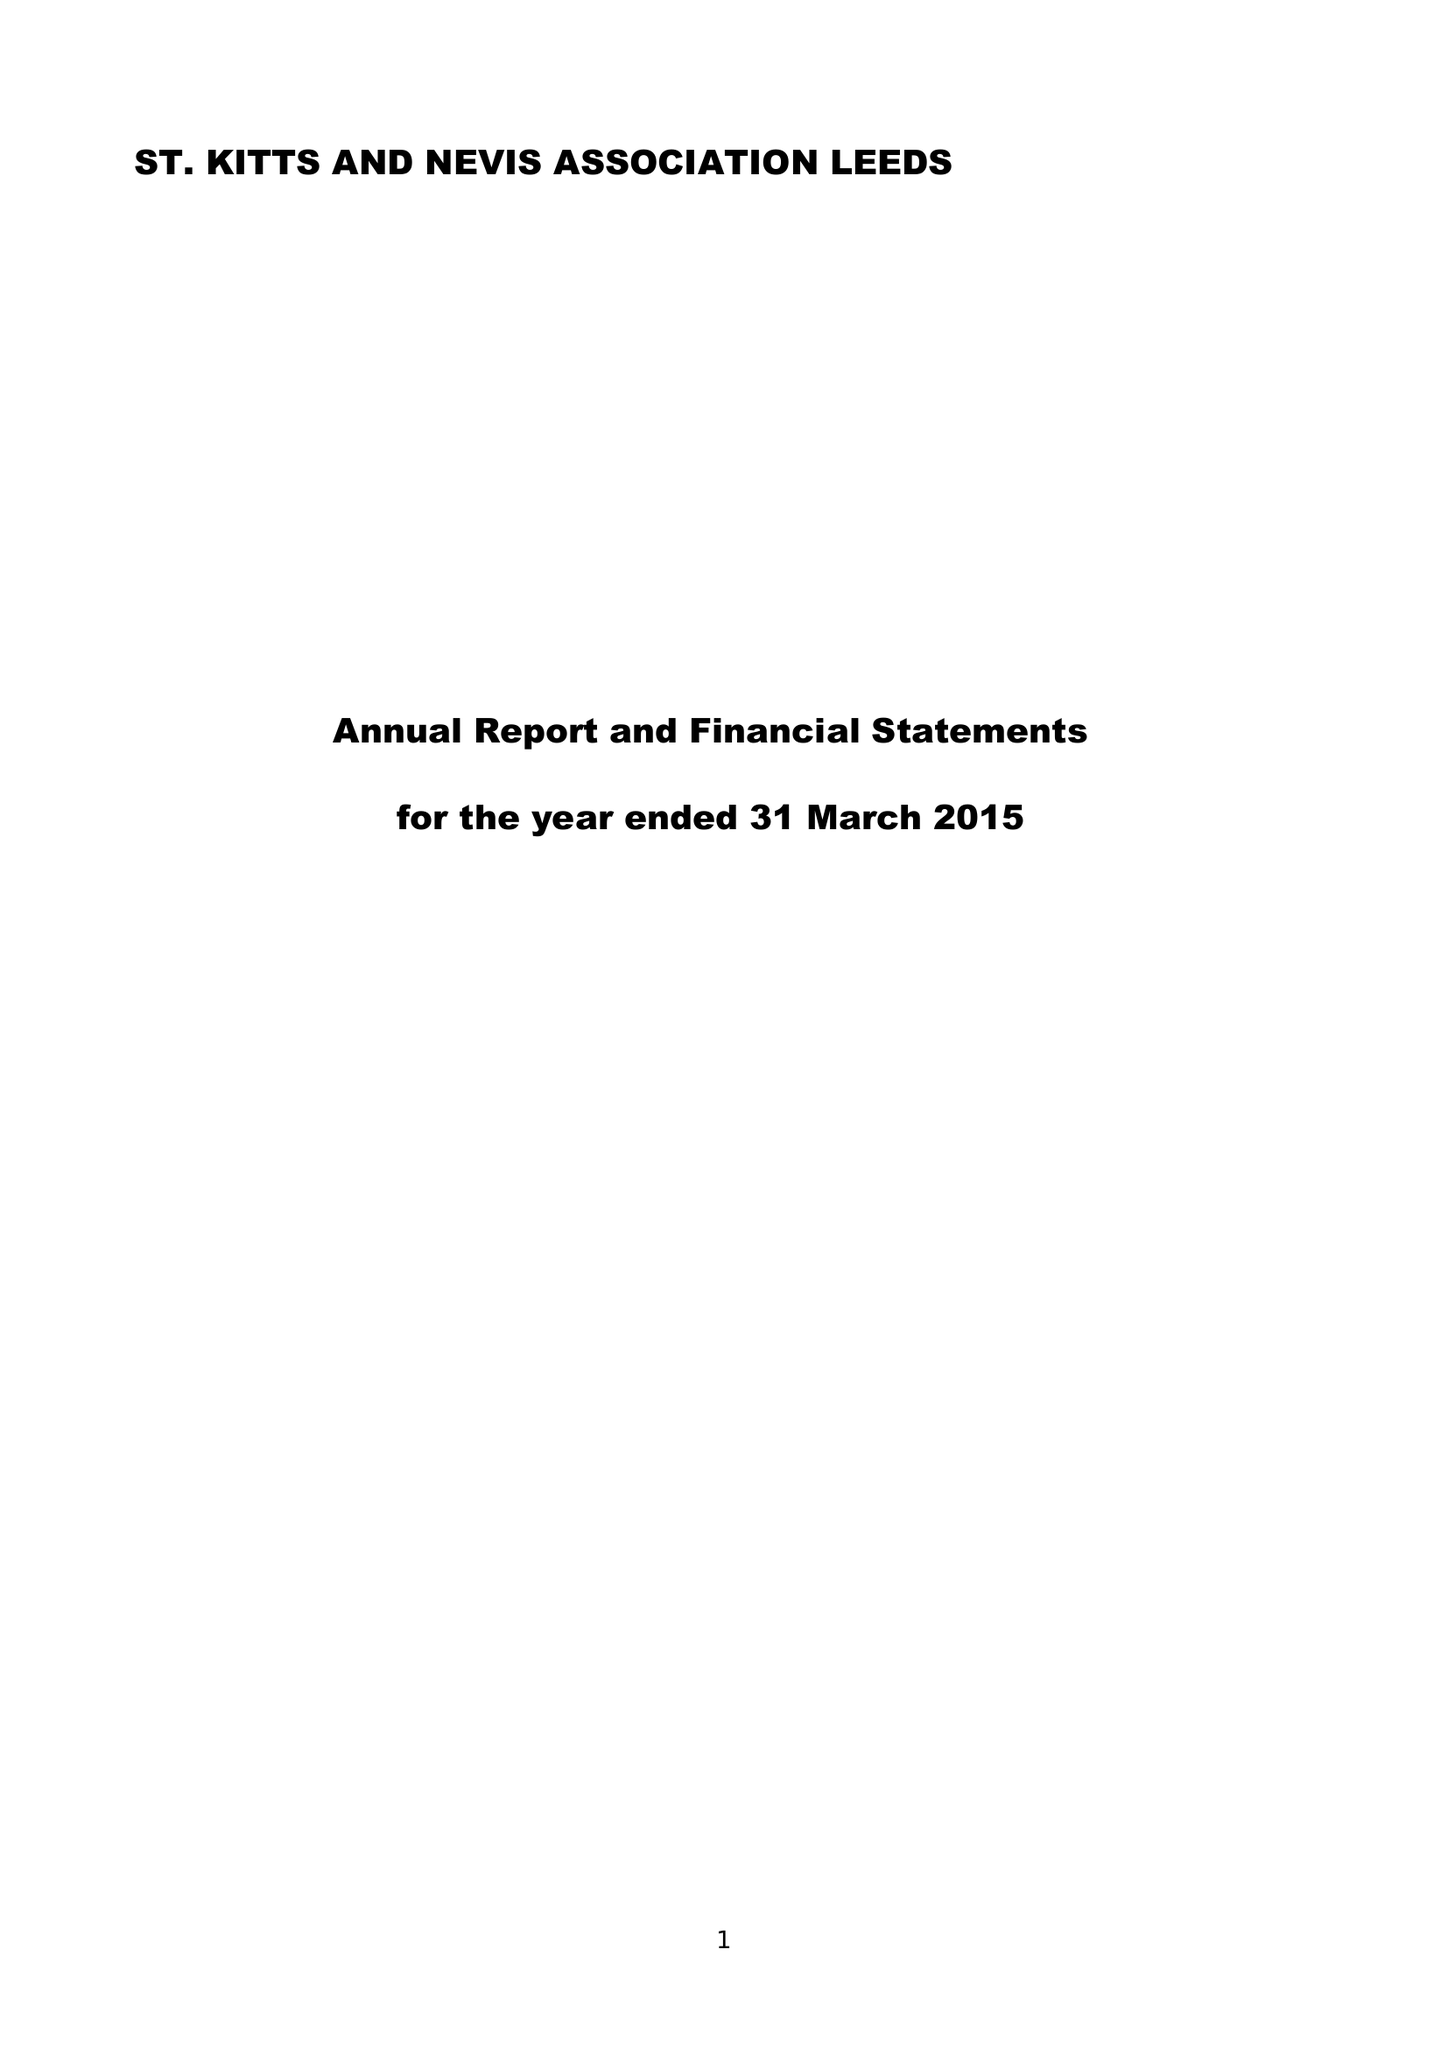What is the value for the address__postcode?
Answer the question using a single word or phrase. LS7 3AF 